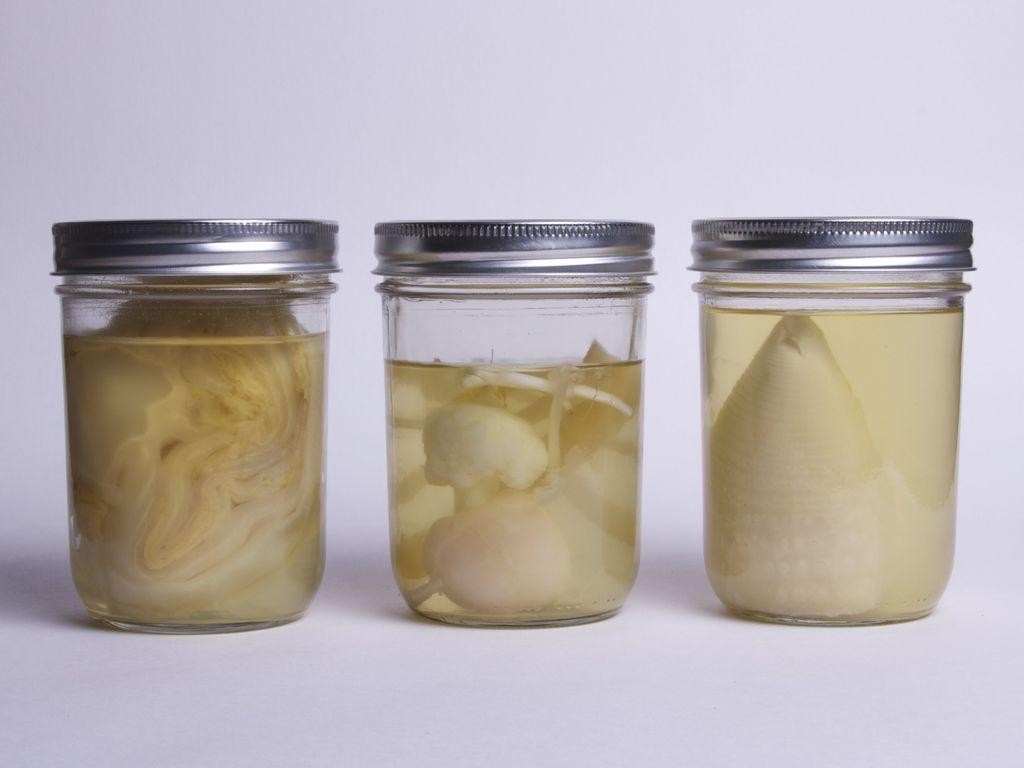How many jars are visible in the image? There are three jars in the image. What is inside the jars? There are liquid-like substances in the jars. What color is the background of the image? The background of the image is white. Can you see any feathers floating in the liquid-like substances in the jars? There are no feathers present in the image, and therefore none can be seen floating in the liquid-like substances in the jars. 